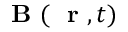<formula> <loc_0><loc_0><loc_500><loc_500>B ( r , t )</formula> 